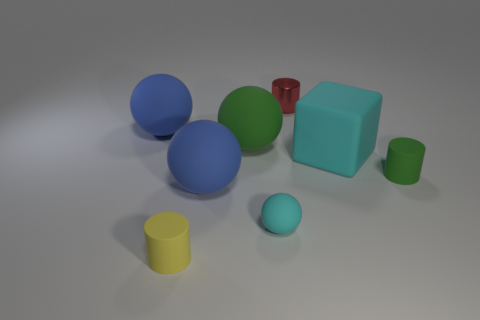Does the yellow cylinder share its color with any other object in the scene? Within this scene, the yellow cylinder is distinct in its hue, and does not share its color with any other object present.  What can you tell me about the lighting in this scene? The lighting seems to be coming from the upper part of the image, creating soft shadows that extend to the right of the objects. This arrangement suggests an overcast tone, which does not create harsh shadows, thereby conveying a calm and balanced scene. 